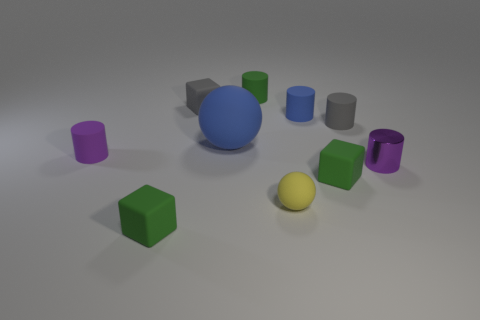Subtract all yellow cubes. How many purple cylinders are left? 2 Subtract all tiny purple cylinders. How many cylinders are left? 3 Subtract 1 blocks. How many blocks are left? 2 Subtract all blue cylinders. How many cylinders are left? 4 Subtract all blocks. How many objects are left? 7 Subtract all gray cylinders. Subtract all purple cubes. How many cylinders are left? 4 Subtract all gray matte cylinders. Subtract all gray matte cylinders. How many objects are left? 8 Add 4 green cylinders. How many green cylinders are left? 5 Add 7 cyan balls. How many cyan balls exist? 7 Subtract 0 green spheres. How many objects are left? 10 